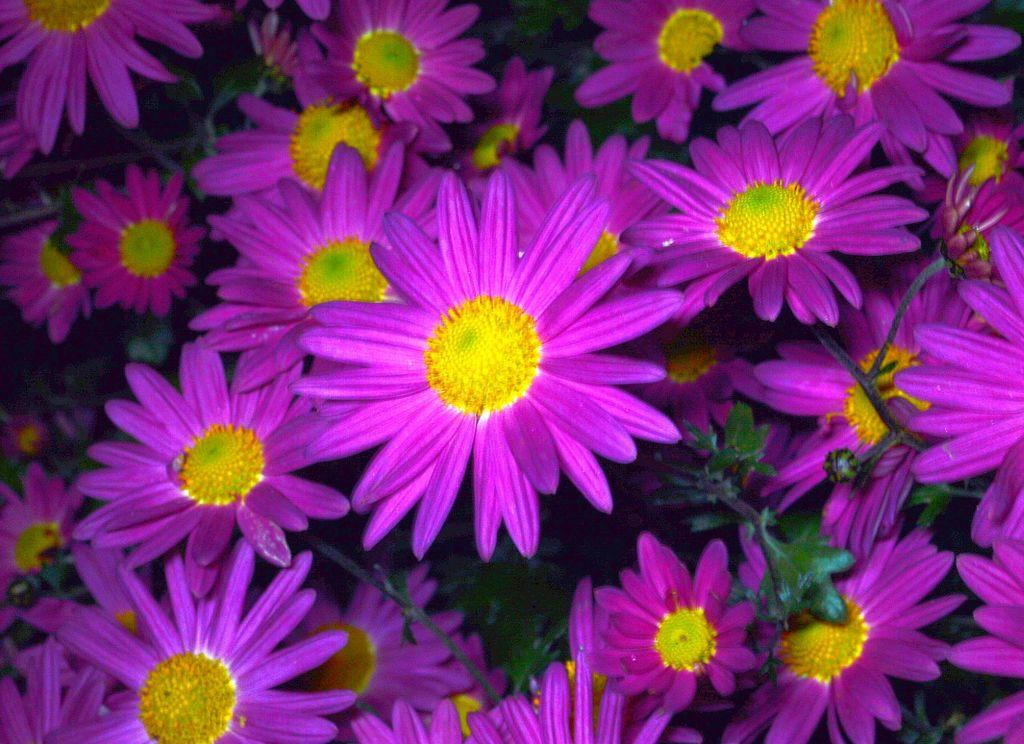What type of plants can be seen in the image? There are flowers in the image. What color are the flowers? The flowers are purple. What can be seen on the flowers in the image? There are pollen grains in the image. What color are the pollen grains? The pollen grains are yellow. Where is the nest of the giant in the image? There is no giant or nest present in the image. What type of root can be seen growing from the flowers in the image? There are no roots visible in the image; it only shows flowers and pollen grains. 